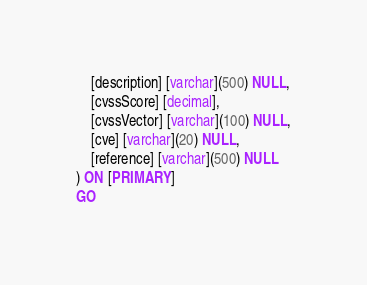<code> <loc_0><loc_0><loc_500><loc_500><_SQL_>	[description] [varchar](500) NULL,
	[cvssScore] [decimal],
	[cvssVector] [varchar](100) NULL,
	[cve] [varchar](20) NULL,
	[reference] [varchar](500) NULL
) ON [PRIMARY]
GO</code> 